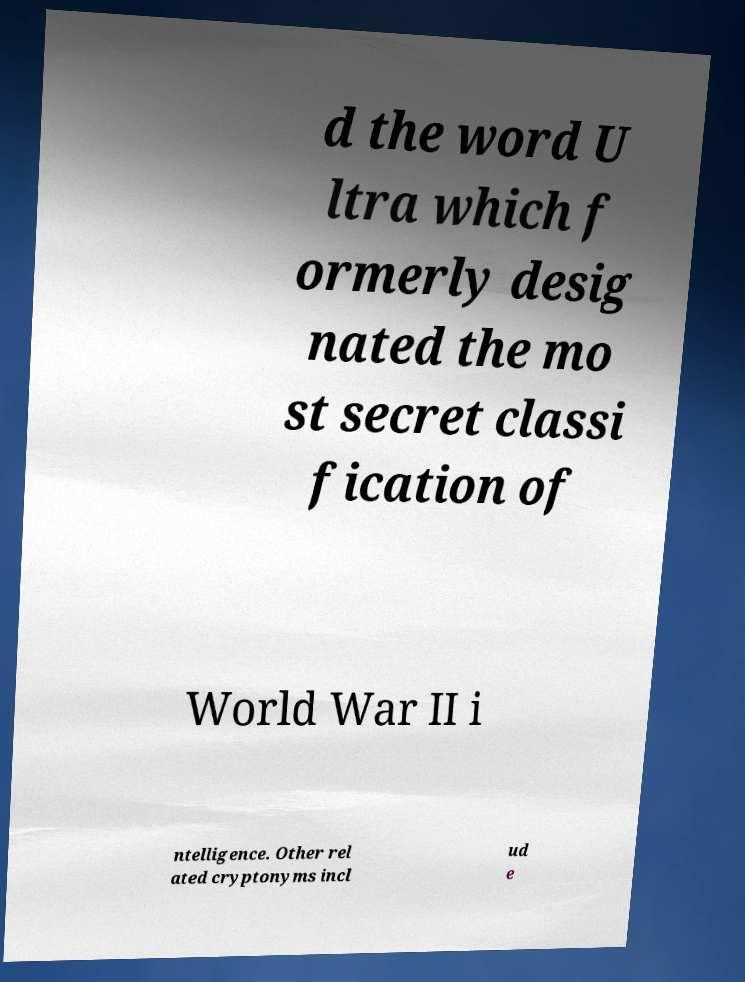What messages or text are displayed in this image? I need them in a readable, typed format. d the word U ltra which f ormerly desig nated the mo st secret classi fication of World War II i ntelligence. Other rel ated cryptonyms incl ud e 